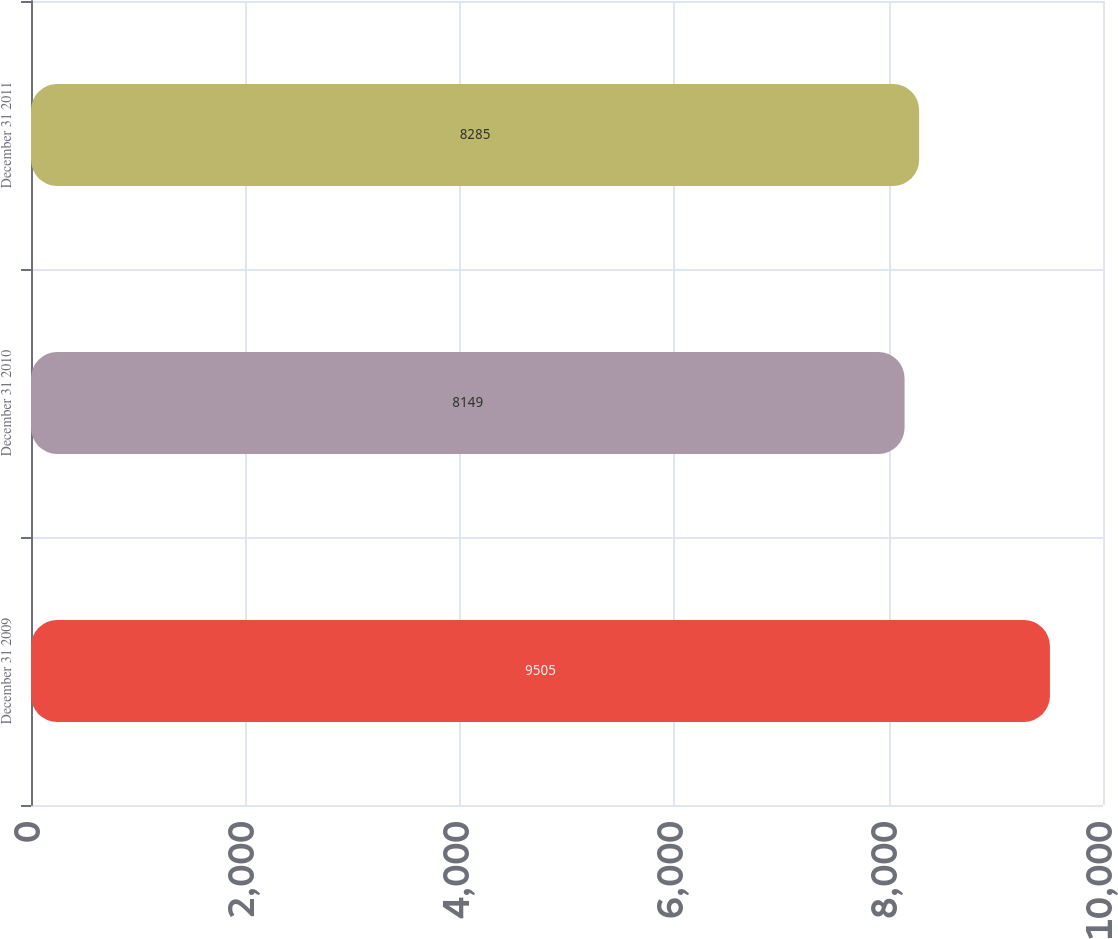<chart> <loc_0><loc_0><loc_500><loc_500><bar_chart><fcel>December 31 2009<fcel>December 31 2010<fcel>December 31 2011<nl><fcel>9505<fcel>8149<fcel>8285<nl></chart> 